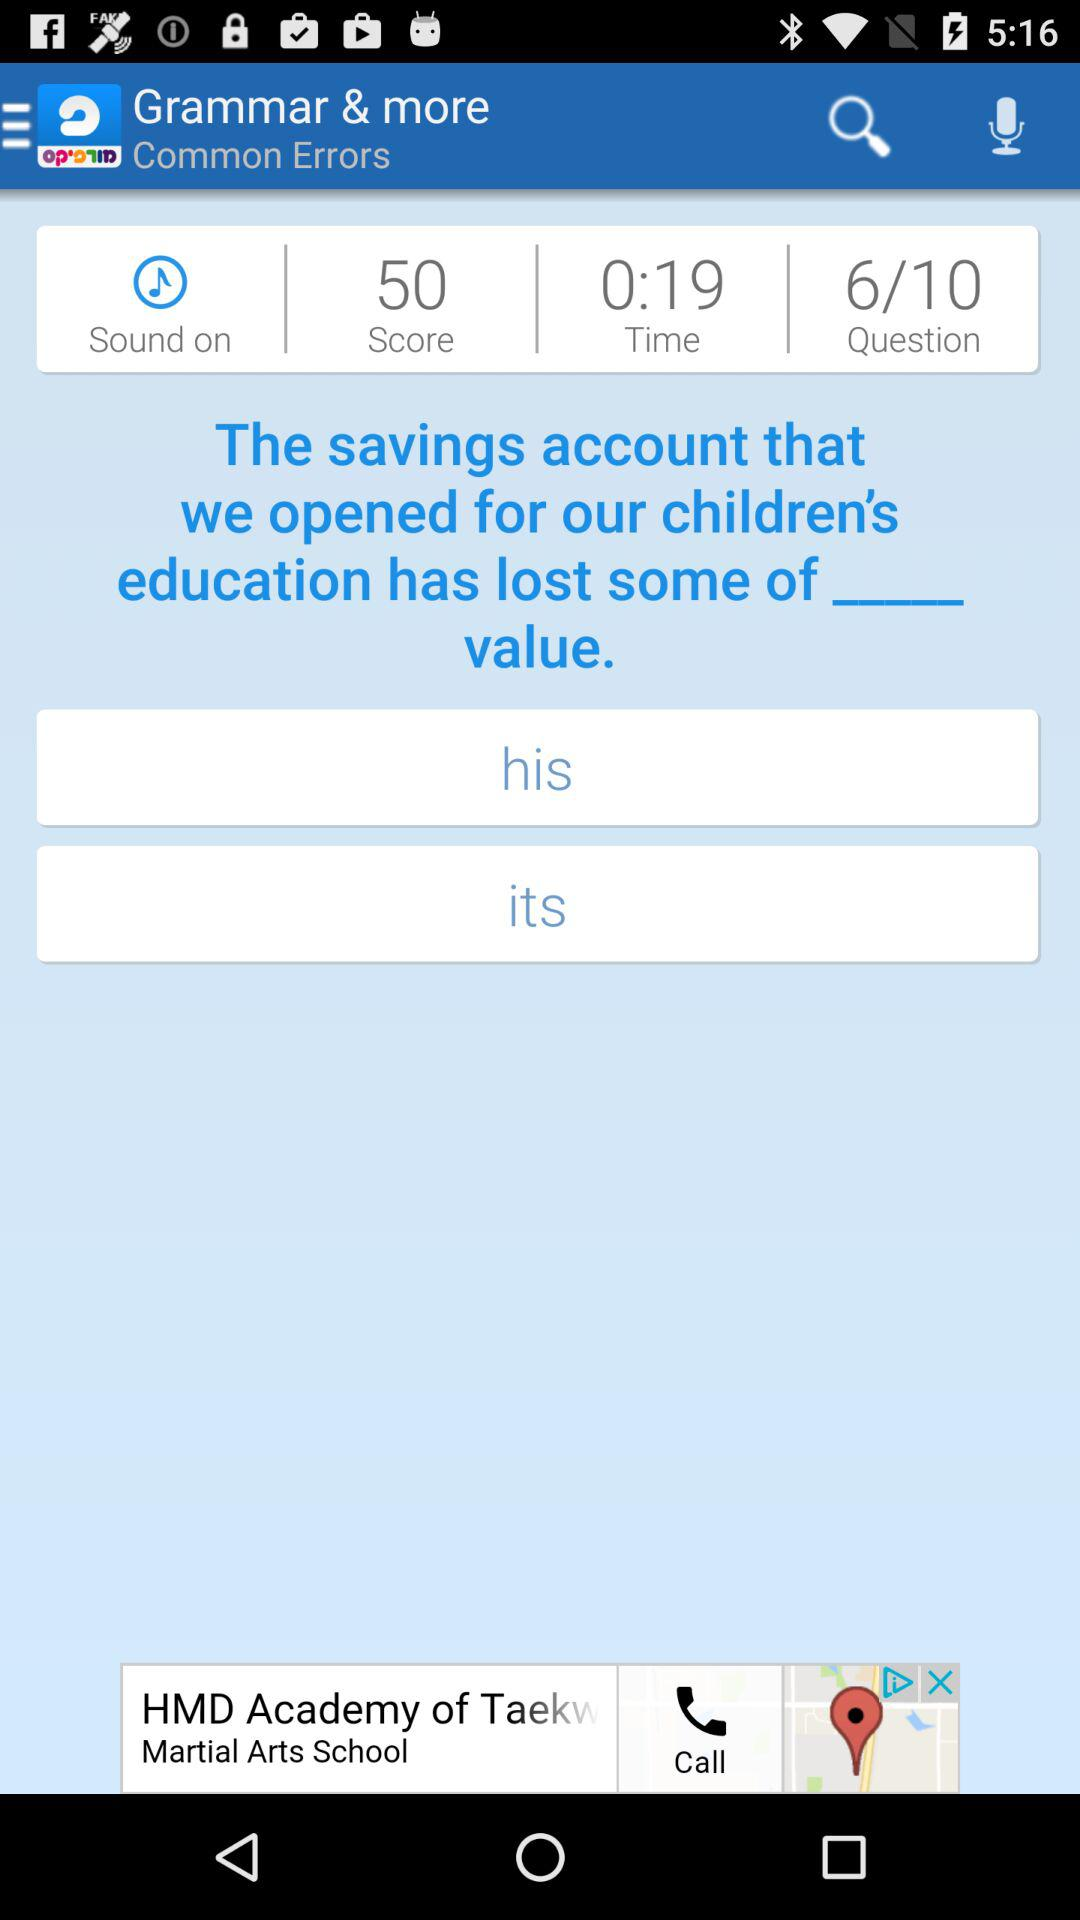How many questions are there? There are 10 questions. 